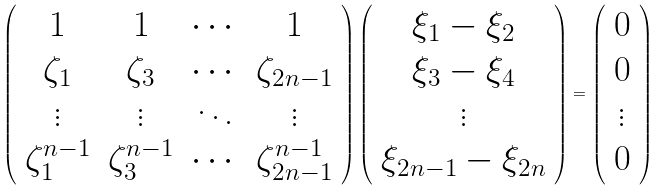Convert formula to latex. <formula><loc_0><loc_0><loc_500><loc_500>\left ( \begin{array} { c c c c } 1 & 1 & \cdots & 1 \\ \zeta _ { 1 } & \zeta _ { 3 } & \cdots & \zeta _ { 2 n - 1 } \\ \vdots & \vdots & \ddots & \vdots \\ \zeta _ { 1 } ^ { n - 1 } & \zeta _ { 3 } ^ { n - 1 } & \cdots & \zeta _ { 2 n - 1 } ^ { n - 1 } \\ \end{array} \right ) \left ( \begin{array} { c } \xi _ { 1 } - \xi _ { 2 } \\ \xi _ { 3 } - \xi _ { 4 } \\ \vdots \\ \xi _ { 2 n - 1 } - \xi _ { 2 n } \\ \end{array} \right ) = \left ( \begin{array} { c } 0 \\ 0 \\ \vdots \\ 0 \end{array} \right )</formula> 